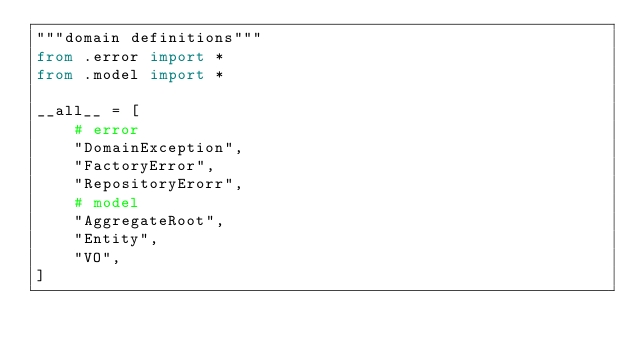Convert code to text. <code><loc_0><loc_0><loc_500><loc_500><_Python_>"""domain definitions"""
from .error import *
from .model import *

__all__ = [
    # error
    "DomainException",
    "FactoryError",
    "RepositoryErorr",
    # model
    "AggregateRoot",
    "Entity",
    "VO",
]
</code> 